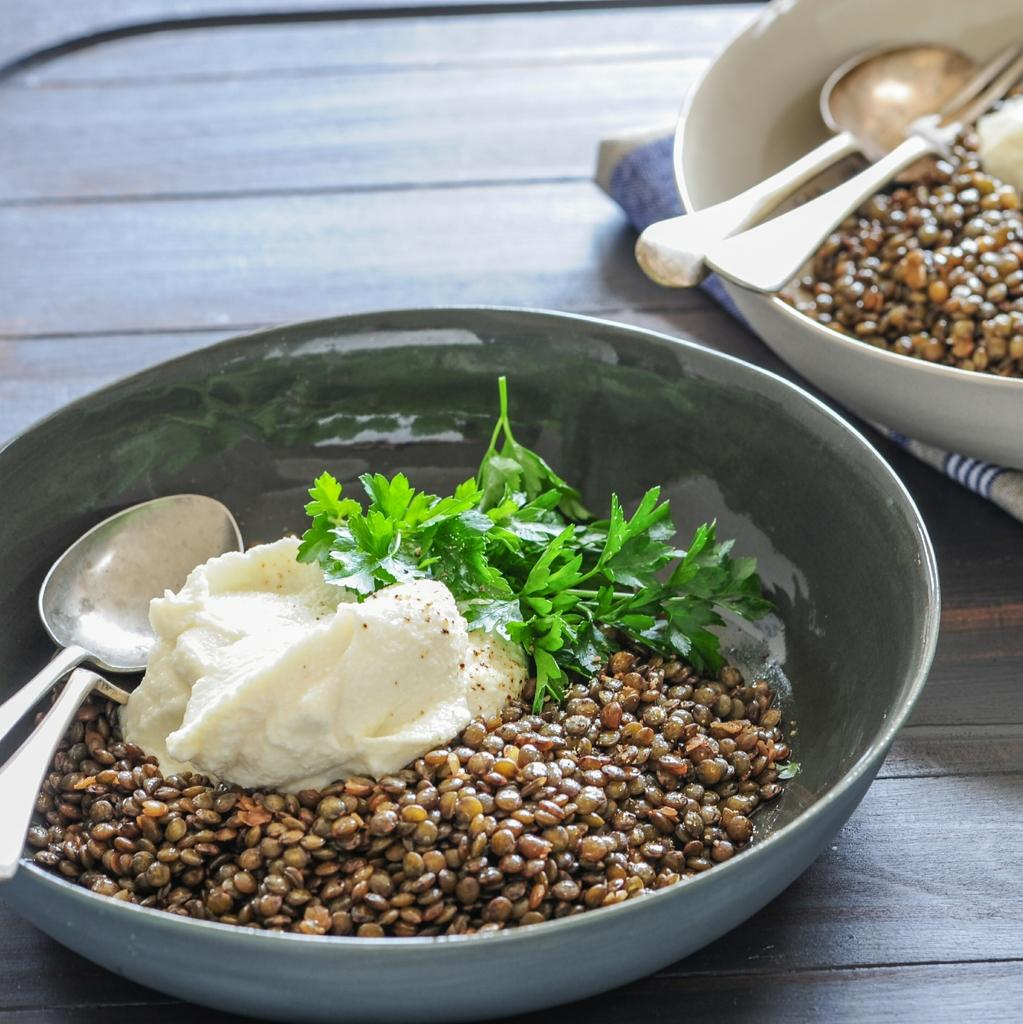What type of food is in the bowls in the image? There are cooked cereals in the image. What accompanies the cooked cereals in the bowls? There is cream in the image. What other items can be seen in the image besides the bowls? There are leaves in the image. How are the cooked cereals and cream served in the image? The items are kept in a bowl. How many bowls are present in the image? There are two bowls in the image. What utensils are in the bowls? There are spoons and forks in the bowls. What type of canvas is visible in the image? There is no canvas present in the image. How does the wave affect the cooked cereals in the image? There is no wave present in the image, so it does not affect the cooked cereals. 